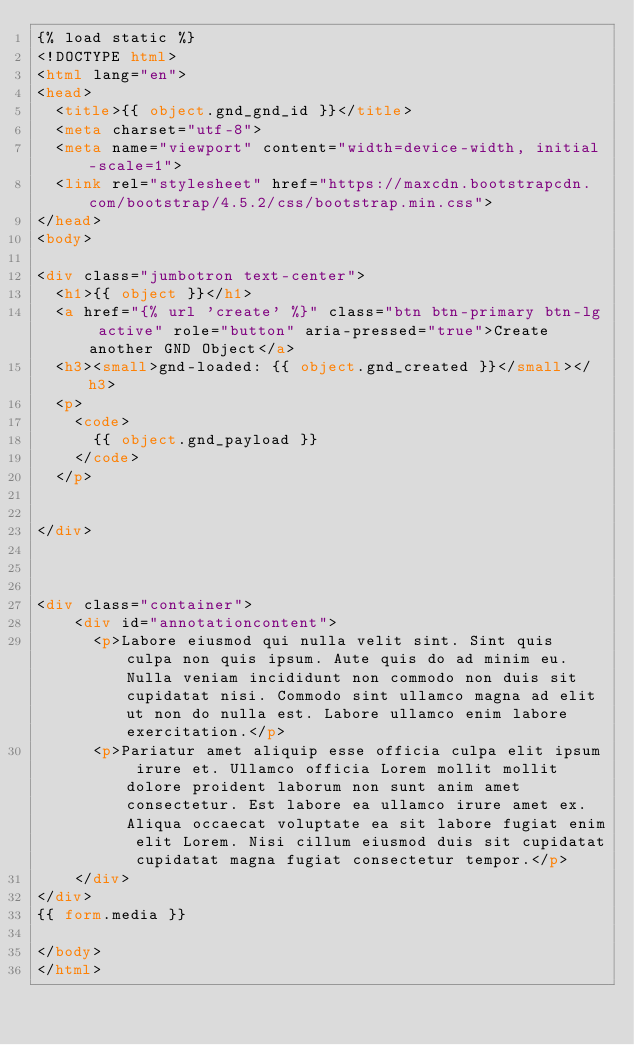Convert code to text. <code><loc_0><loc_0><loc_500><loc_500><_HTML_>{% load static %}
<!DOCTYPE html>
<html lang="en">
<head>
  <title>{{ object.gnd_gnd_id }}</title>
  <meta charset="utf-8">
  <meta name="viewport" content="width=device-width, initial-scale=1">
  <link rel="stylesheet" href="https://maxcdn.bootstrapcdn.com/bootstrap/4.5.2/css/bootstrap.min.css">
</head>
<body>

<div class="jumbotron text-center">
  <h1>{{ object }}</h1>
  <a href="{% url 'create' %}" class="btn btn-primary btn-lg active" role="button" aria-pressed="true">Create another GND Object</a>
  <h3><small>gnd-loaded: {{ object.gnd_created }}</small></h3>
  <p>
    <code>
      {{ object.gnd_payload }}
    </code>
  </p>
  

</div>


  
<div class="container">
    <div id="annotationcontent">
      <p>Labore eiusmod qui nulla velit sint. Sint quis culpa non quis ipsum. Aute quis do ad minim eu. Nulla veniam incididunt non commodo non duis sit cupidatat nisi. Commodo sint ullamco magna ad elit ut non do nulla est. Labore ullamco enim labore exercitation.</p>
      <p>Pariatur amet aliquip esse officia culpa elit ipsum irure et. Ullamco officia Lorem mollit mollit dolore proident laborum non sunt anim amet consectetur. Est labore ea ullamco irure amet ex. Aliqua occaecat voluptate ea sit labore fugiat enim elit Lorem. Nisi cillum eiusmod duis sit cupidatat cupidatat magna fugiat consectetur tempor.</p>
    </div> 
</div>
{{ form.media }}

</body>
</html></code> 